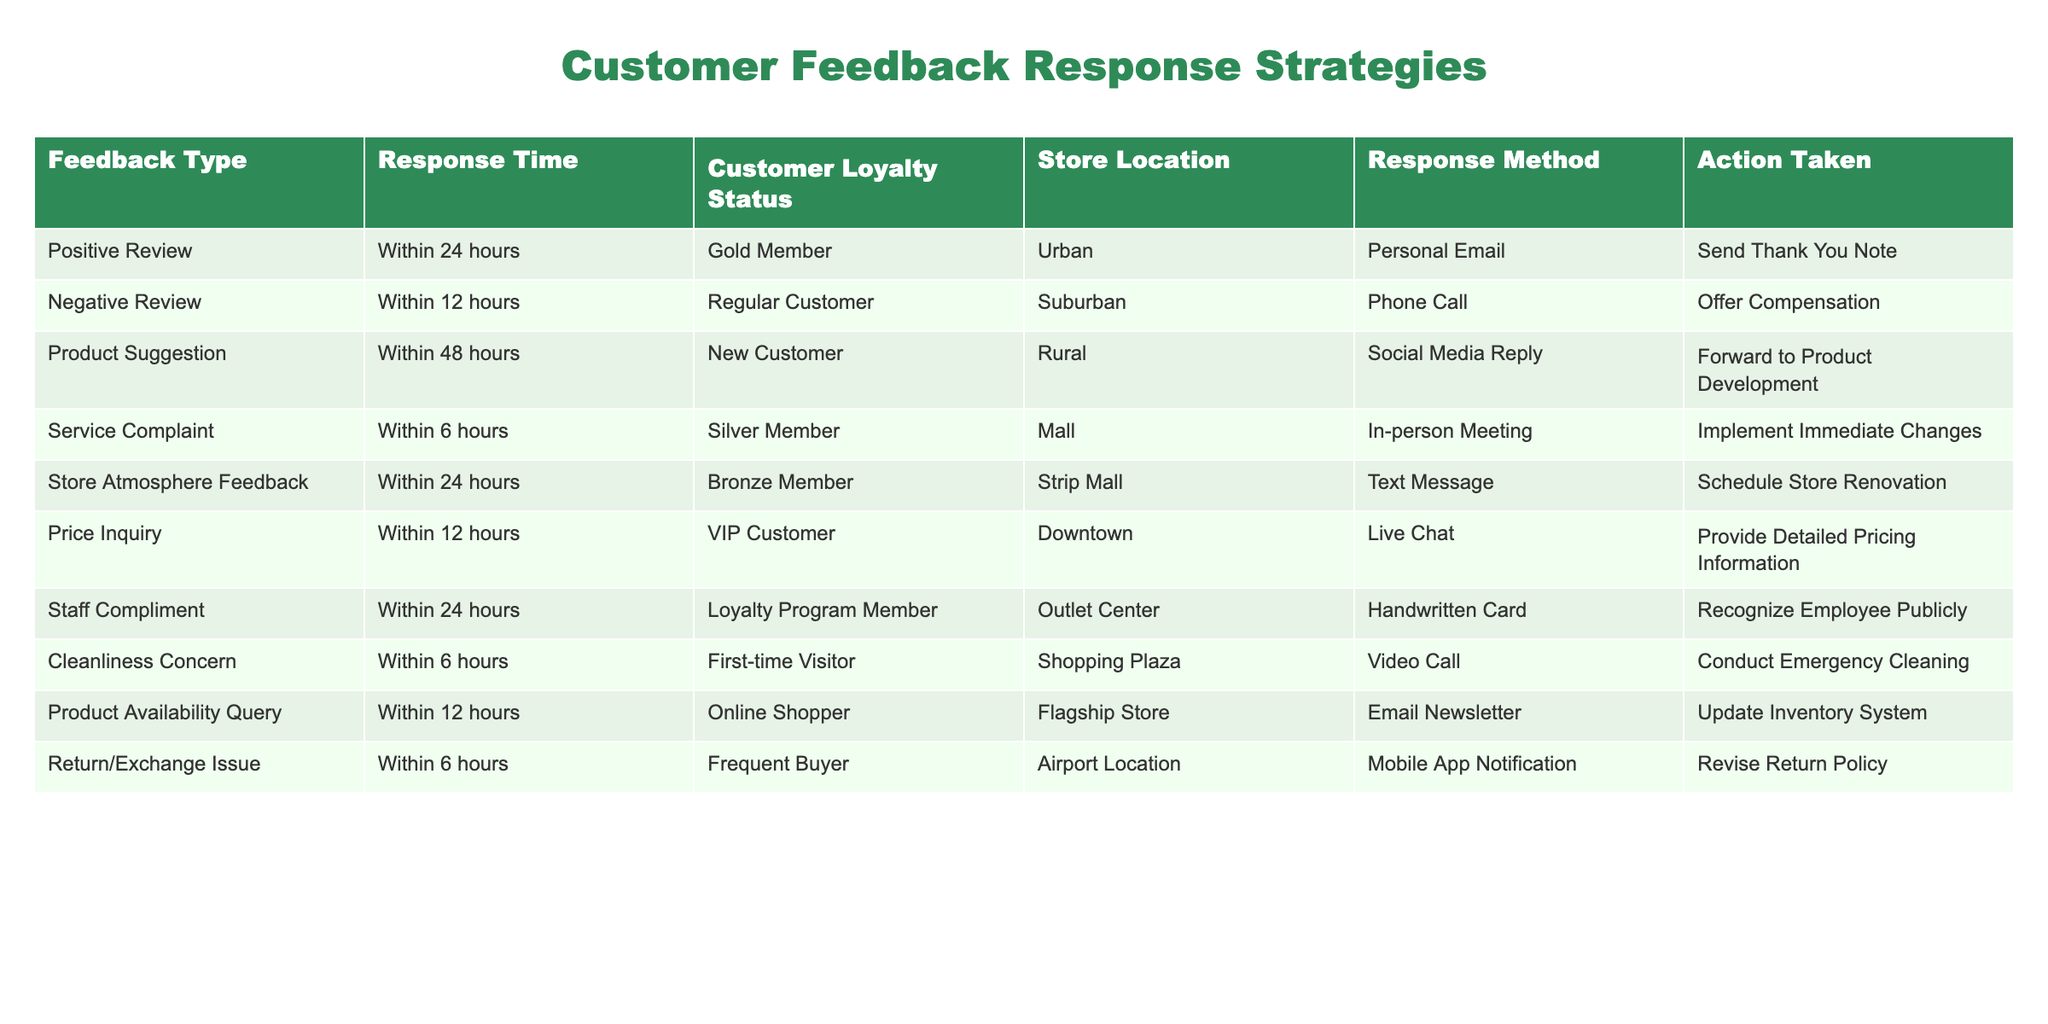What is the response method used for negative reviews? According to the table, negative reviews are addressed via phone calls. This can be found in the row corresponding to the negative review feedback type.
Answer: Phone Call How long does it take to respond to a service complaint? The table shows that service complaints are responded to within 6 hours, as indicated in the respective row for service complaint feedback.
Answer: Within 6 hours Is it true that all positive reviews receive a personal email response? Yes, this is confirmed by reviewing the response methods for positive review feedback, where a personal email is indeed the method used for addressing feedback of this type.
Answer: Yes What action is taken for product suggestions? Looking at the row for product suggestions, the action taken is to forward the feedback to product development, as stated in the action taken column.
Answer: Forward to Product Development How many feedback types have a response time of less than 12 hours? To find this total, I will review the rows with response times of less than 12 hours, which includes negative reviews, service complaints, and return/exchange issues. The total count is 3 feedback types.
Answer: 3 Which customer loyalty status corresponds to the store atmosphere feedback? By checking the relevant row in the table, store atmosphere feedback is linked to bronze members, as noted in the customer loyalty status column.
Answer: Bronze Member What is the response method for price inquiries? The table indicates that price inquiries are handled through live chat, corresponding to the row listing the price inquiry feedback type.
Answer: Live Chat Can a first-time visitor receive an email response? No, the table suggests that first-time visitors are responded to through a video call for cleanliness concerns, not via email, showing that this is not the method used for them.
Answer: No What are the differences in response times between service complaints and product availability queries? The response time for service complaints is 6 hours, while for product availability queries, it is 12 hours. The difference is 12 - 6, which equals 6 hours.
Answer: 6 hours 